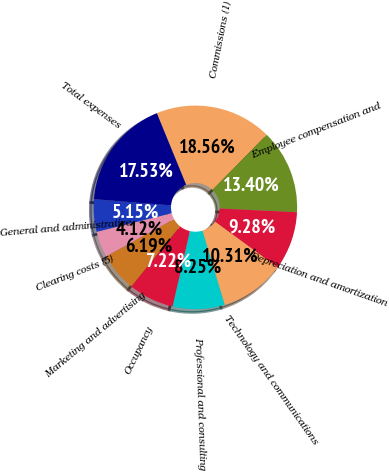<chart> <loc_0><loc_0><loc_500><loc_500><pie_chart><fcel>Commissions (1)<fcel>Employee compensation and<fcel>Depreciation and amortization<fcel>Technology and communications<fcel>Professional and consulting<fcel>Occupancy<fcel>Marketing and advertising<fcel>Clearing costs (5)<fcel>General and administrative<fcel>Total expenses<nl><fcel>18.56%<fcel>13.4%<fcel>9.28%<fcel>10.31%<fcel>8.25%<fcel>7.22%<fcel>6.19%<fcel>4.12%<fcel>5.15%<fcel>17.53%<nl></chart> 